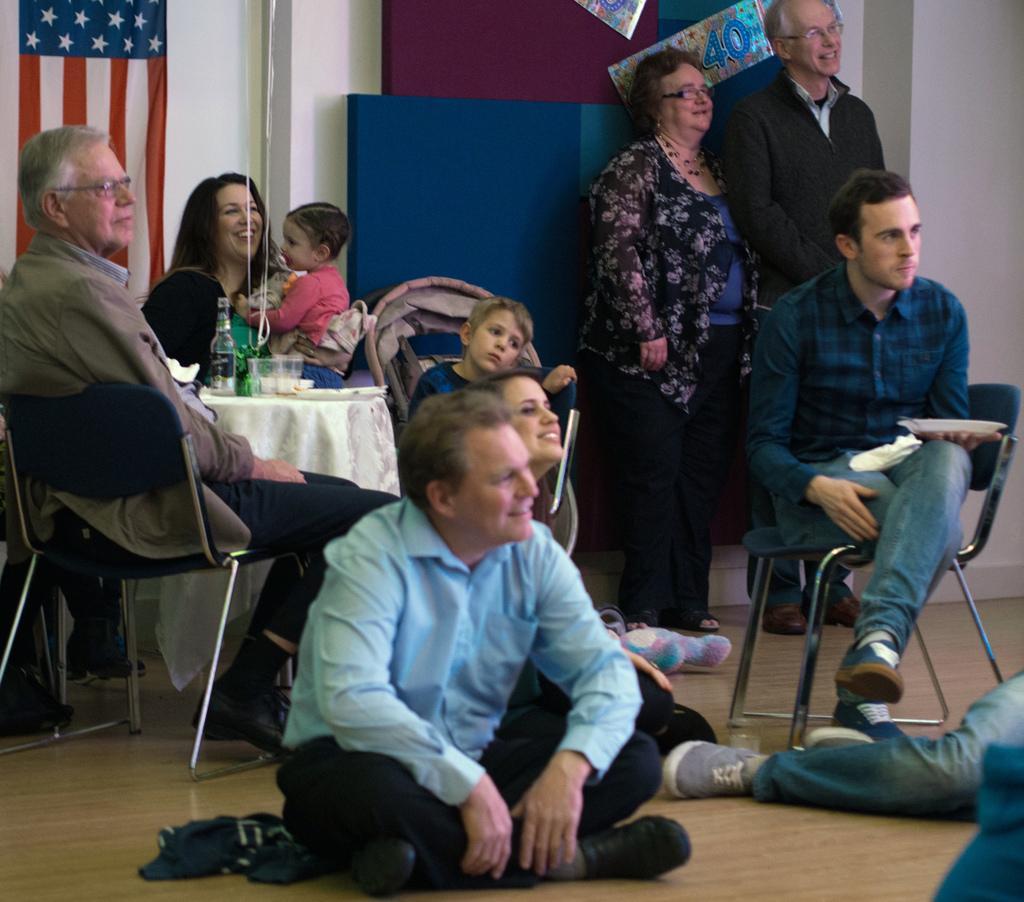Please provide a concise description of this image. In this picture we can see some people sitting on chairs, in the background there are two persons standing here, on the left side there is a flag, we can see a person sitting on the floor, in the background there is a wall, we can see a table where, there is a bottle and glass on the table. 